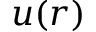<formula> <loc_0><loc_0><loc_500><loc_500>u ( r )</formula> 